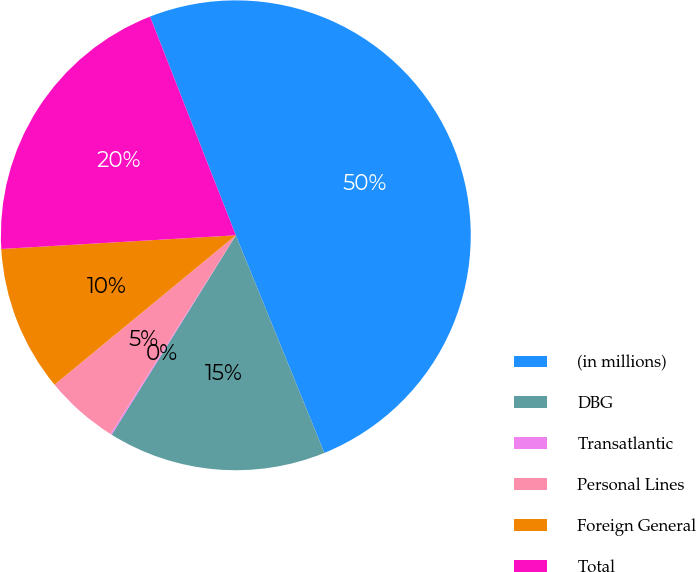Convert chart. <chart><loc_0><loc_0><loc_500><loc_500><pie_chart><fcel>(in millions)<fcel>DBG<fcel>Transatlantic<fcel>Personal Lines<fcel>Foreign General<fcel>Total<nl><fcel>49.8%<fcel>15.01%<fcel>0.1%<fcel>5.07%<fcel>10.04%<fcel>19.98%<nl></chart> 